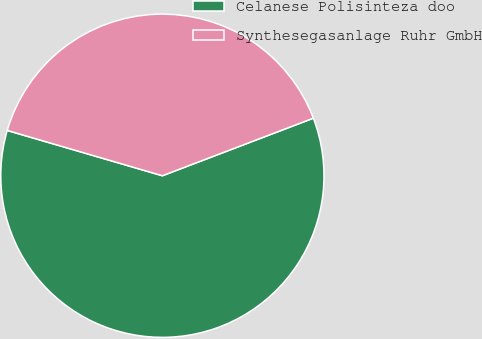<chart> <loc_0><loc_0><loc_500><loc_500><pie_chart><fcel>Celanese Polisinteza doo<fcel>Synthesegasanlage Ruhr GmbH<nl><fcel>60.32%<fcel>39.68%<nl></chart> 